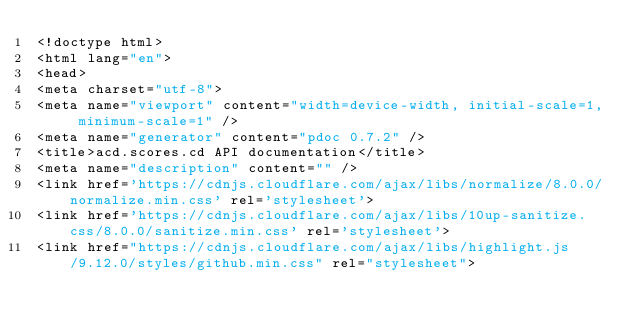Convert code to text. <code><loc_0><loc_0><loc_500><loc_500><_HTML_><!doctype html>
<html lang="en">
<head>
<meta charset="utf-8">
<meta name="viewport" content="width=device-width, initial-scale=1, minimum-scale=1" />
<meta name="generator" content="pdoc 0.7.2" />
<title>acd.scores.cd API documentation</title>
<meta name="description" content="" />
<link href='https://cdnjs.cloudflare.com/ajax/libs/normalize/8.0.0/normalize.min.css' rel='stylesheet'>
<link href='https://cdnjs.cloudflare.com/ajax/libs/10up-sanitize.css/8.0.0/sanitize.min.css' rel='stylesheet'>
<link href="https://cdnjs.cloudflare.com/ajax/libs/highlight.js/9.12.0/styles/github.min.css" rel="stylesheet"></code> 